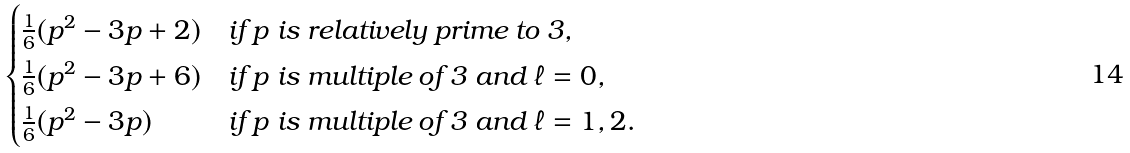<formula> <loc_0><loc_0><loc_500><loc_500>\begin{cases} \frac { 1 } { 6 } ( p ^ { 2 } - 3 p + 2 ) & \text {if $p$ is relatively prime to 3,} \\ \frac { 1 } { 6 } ( p ^ { 2 } - 3 p + 6 ) & \text {if $p$ is multiple of 3 and $\ell=0$,} \\ \frac { 1 } { 6 } ( p ^ { 2 } - 3 p ) & \text {if $p$ is multiple of 3 and $\ell=1,2$.} \end{cases}</formula> 